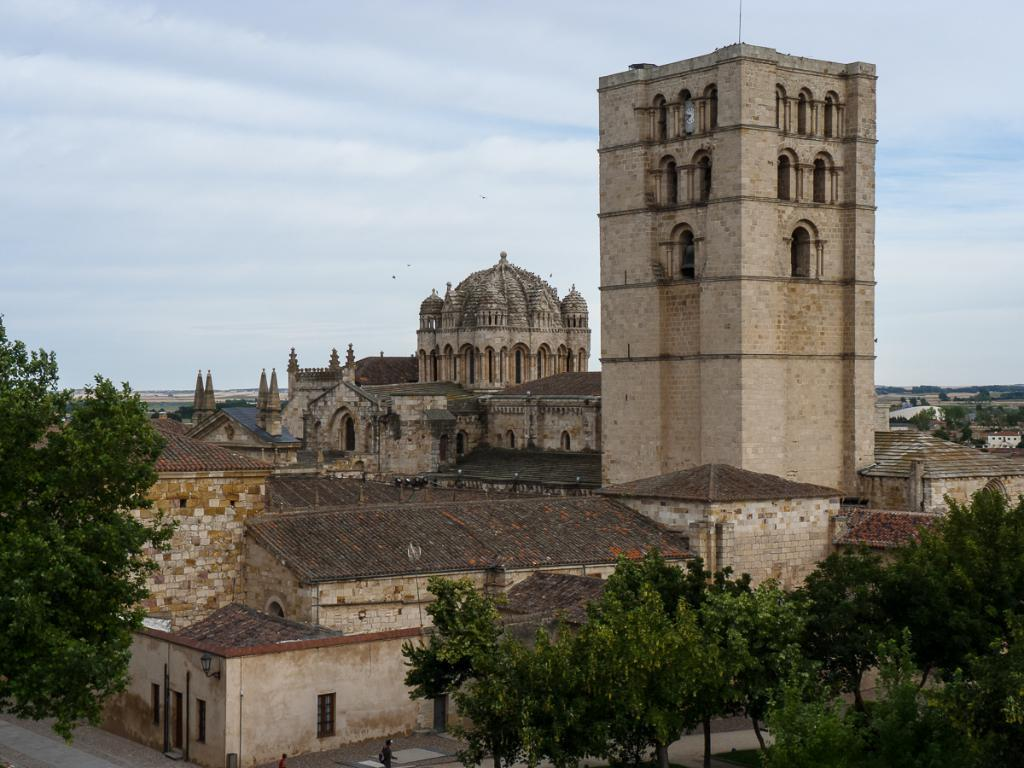What type of structures can be seen in the image? There are buildings in the image. What other natural elements are present in the image? There are trees in the image. Is there any man-made infrastructure visible in the image? Yes, there is a road in the image. What is visible in the background of the image? The sky is visible in the image, and clouds are present in the sky. Can you hear the trees folding in the image? There is no sound or action associated with the trees in the image, so it is not possible to hear them folding. 